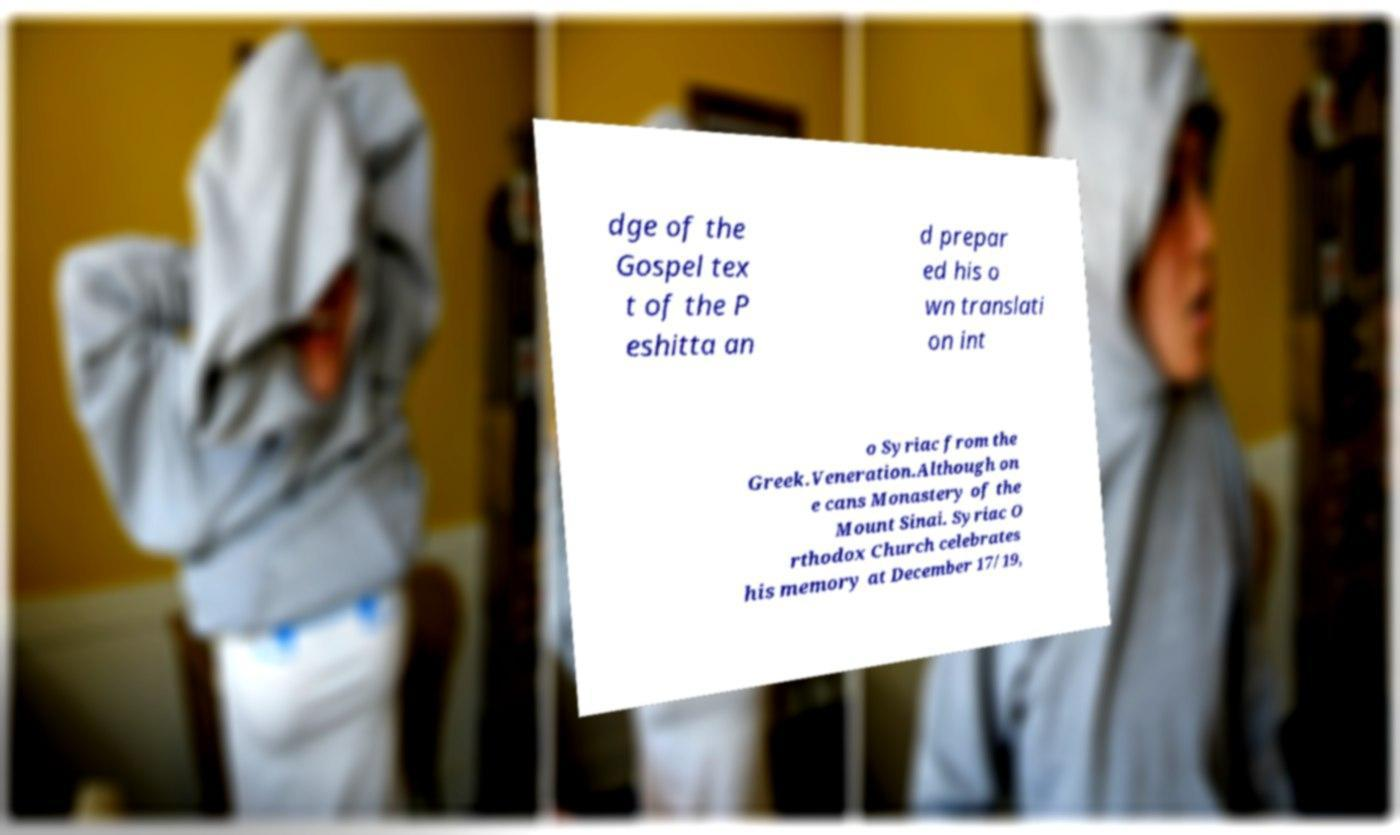What messages or text are displayed in this image? I need them in a readable, typed format. dge of the Gospel tex t of the P eshitta an d prepar ed his o wn translati on int o Syriac from the Greek.Veneration.Although on e cans Monastery of the Mount Sinai. Syriac O rthodox Church celebrates his memory at December 17/19, 